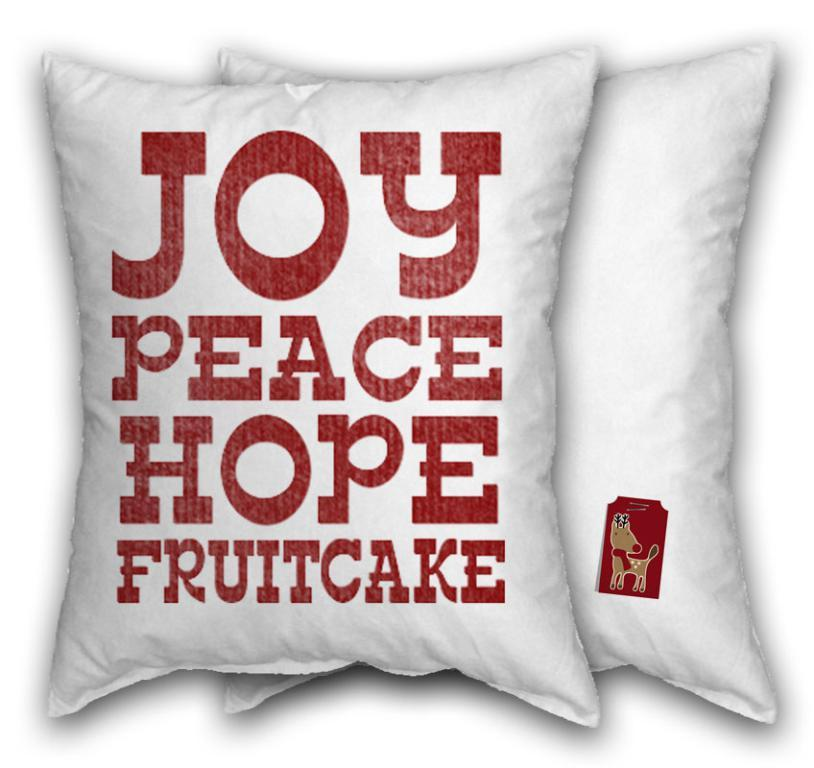What object can be seen in the image? There is a pillow in the image. What is unique about the pillow? The pillow has text on it. What type of drink is the daughter holding in the image? There is no daughter or drink present in the image; it only features a pillow with text on it. 